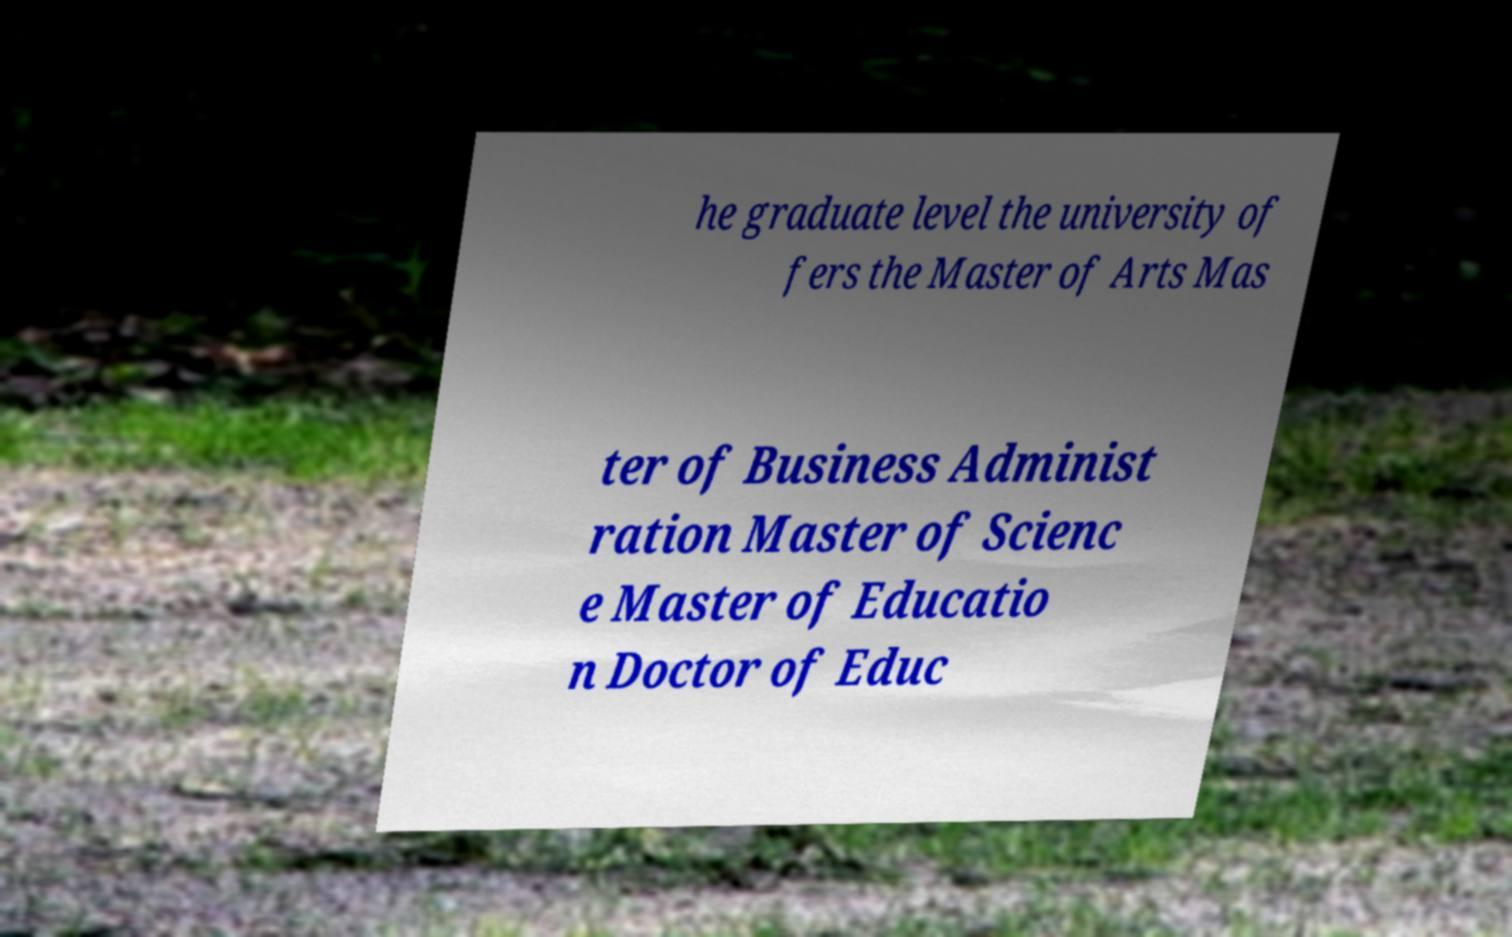I need the written content from this picture converted into text. Can you do that? he graduate level the university of fers the Master of Arts Mas ter of Business Administ ration Master of Scienc e Master of Educatio n Doctor of Educ 